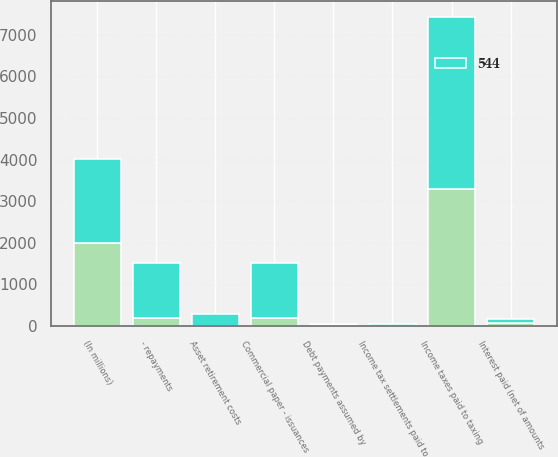<chart> <loc_0><loc_0><loc_500><loc_500><stacked_bar_chart><ecel><fcel>(In millions)<fcel>Interest paid (net of amounts<fcel>Income taxes paid to taxing<fcel>Income tax settlements paid to<fcel>Commercial paper - issuances<fcel>- repayments<fcel>Asset retirement costs<fcel>Debt payments assumed by<nl><fcel>nan<fcel>2007<fcel>66<fcel>3283<fcel>13<fcel>191<fcel>191<fcel>8<fcel>21<nl><fcel>544<fcel>2006<fcel>96<fcel>4149<fcel>35<fcel>1321<fcel>1321<fcel>286<fcel>24<nl></chart> 